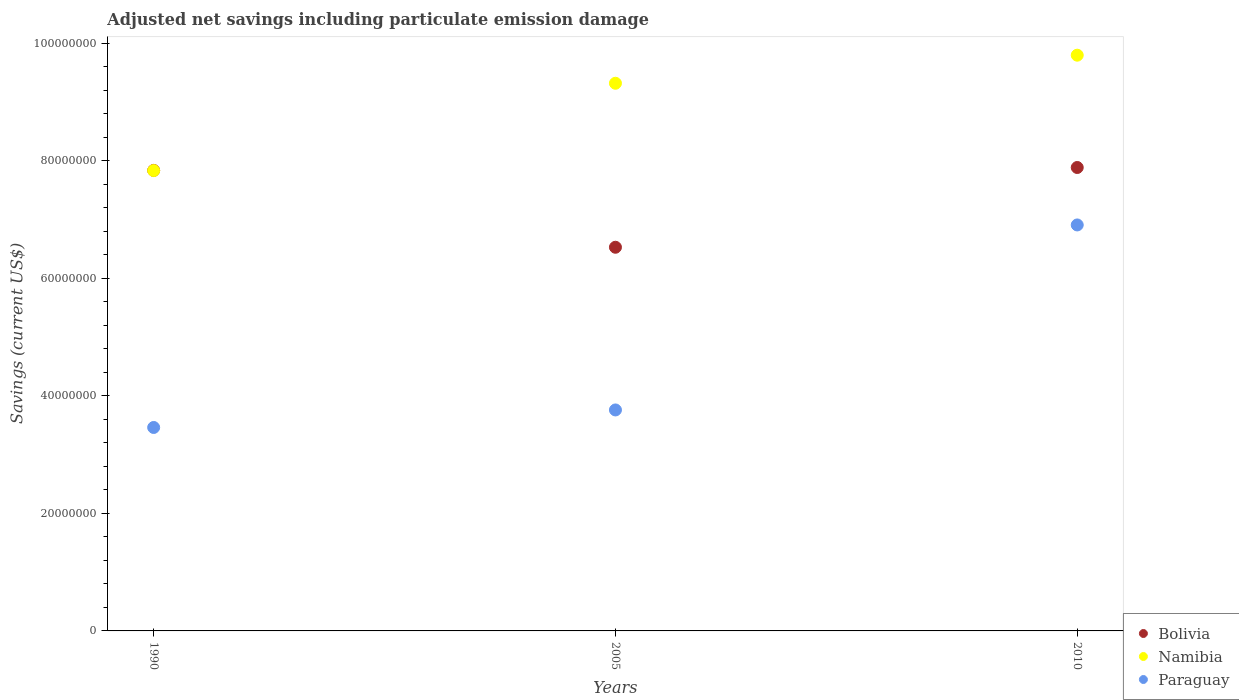How many different coloured dotlines are there?
Keep it short and to the point. 3. What is the net savings in Namibia in 1990?
Your response must be concise. 7.84e+07. Across all years, what is the maximum net savings in Bolivia?
Give a very brief answer. 7.89e+07. Across all years, what is the minimum net savings in Paraguay?
Your answer should be compact. 3.46e+07. In which year was the net savings in Namibia minimum?
Offer a very short reply. 1990. What is the total net savings in Bolivia in the graph?
Provide a succinct answer. 2.23e+08. What is the difference between the net savings in Paraguay in 1990 and that in 2005?
Offer a terse response. -2.98e+06. What is the difference between the net savings in Namibia in 1990 and the net savings in Paraguay in 2005?
Provide a short and direct response. 4.07e+07. What is the average net savings in Paraguay per year?
Provide a short and direct response. 4.71e+07. In the year 2005, what is the difference between the net savings in Paraguay and net savings in Bolivia?
Your answer should be very brief. -2.77e+07. In how many years, is the net savings in Namibia greater than 88000000 US$?
Ensure brevity in your answer.  2. What is the ratio of the net savings in Namibia in 1990 to that in 2010?
Ensure brevity in your answer.  0.8. Is the difference between the net savings in Paraguay in 1990 and 2005 greater than the difference between the net savings in Bolivia in 1990 and 2005?
Give a very brief answer. No. What is the difference between the highest and the second highest net savings in Namibia?
Offer a very short reply. 4.78e+06. What is the difference between the highest and the lowest net savings in Bolivia?
Your response must be concise. 1.36e+07. In how many years, is the net savings in Paraguay greater than the average net savings in Paraguay taken over all years?
Offer a terse response. 1. Does the net savings in Paraguay monotonically increase over the years?
Give a very brief answer. Yes. Is the net savings in Paraguay strictly greater than the net savings in Bolivia over the years?
Ensure brevity in your answer.  No. What is the difference between two consecutive major ticks on the Y-axis?
Offer a very short reply. 2.00e+07. Are the values on the major ticks of Y-axis written in scientific E-notation?
Give a very brief answer. No. Does the graph contain any zero values?
Keep it short and to the point. No. Does the graph contain grids?
Offer a very short reply. No. Where does the legend appear in the graph?
Provide a succinct answer. Bottom right. How are the legend labels stacked?
Offer a terse response. Vertical. What is the title of the graph?
Your answer should be compact. Adjusted net savings including particulate emission damage. What is the label or title of the X-axis?
Provide a short and direct response. Years. What is the label or title of the Y-axis?
Offer a terse response. Savings (current US$). What is the Savings (current US$) in Bolivia in 1990?
Offer a very short reply. 7.84e+07. What is the Savings (current US$) of Namibia in 1990?
Your answer should be compact. 7.84e+07. What is the Savings (current US$) in Paraguay in 1990?
Offer a terse response. 3.46e+07. What is the Savings (current US$) in Bolivia in 2005?
Offer a terse response. 6.53e+07. What is the Savings (current US$) in Namibia in 2005?
Give a very brief answer. 9.32e+07. What is the Savings (current US$) of Paraguay in 2005?
Offer a terse response. 3.76e+07. What is the Savings (current US$) in Bolivia in 2010?
Make the answer very short. 7.89e+07. What is the Savings (current US$) in Namibia in 2010?
Provide a succinct answer. 9.80e+07. What is the Savings (current US$) of Paraguay in 2010?
Provide a short and direct response. 6.91e+07. Across all years, what is the maximum Savings (current US$) in Bolivia?
Your answer should be compact. 7.89e+07. Across all years, what is the maximum Savings (current US$) of Namibia?
Make the answer very short. 9.80e+07. Across all years, what is the maximum Savings (current US$) of Paraguay?
Offer a terse response. 6.91e+07. Across all years, what is the minimum Savings (current US$) of Bolivia?
Make the answer very short. 6.53e+07. Across all years, what is the minimum Savings (current US$) in Namibia?
Provide a short and direct response. 7.84e+07. Across all years, what is the minimum Savings (current US$) of Paraguay?
Your answer should be very brief. 3.46e+07. What is the total Savings (current US$) of Bolivia in the graph?
Your answer should be very brief. 2.23e+08. What is the total Savings (current US$) in Namibia in the graph?
Offer a terse response. 2.70e+08. What is the total Savings (current US$) of Paraguay in the graph?
Keep it short and to the point. 1.41e+08. What is the difference between the Savings (current US$) in Bolivia in 1990 and that in 2005?
Make the answer very short. 1.31e+07. What is the difference between the Savings (current US$) of Namibia in 1990 and that in 2005?
Provide a short and direct response. -1.49e+07. What is the difference between the Savings (current US$) of Paraguay in 1990 and that in 2005?
Offer a terse response. -2.98e+06. What is the difference between the Savings (current US$) in Bolivia in 1990 and that in 2010?
Make the answer very short. -4.93e+05. What is the difference between the Savings (current US$) of Namibia in 1990 and that in 2010?
Your answer should be compact. -1.96e+07. What is the difference between the Savings (current US$) of Paraguay in 1990 and that in 2010?
Your response must be concise. -3.45e+07. What is the difference between the Savings (current US$) in Bolivia in 2005 and that in 2010?
Offer a very short reply. -1.36e+07. What is the difference between the Savings (current US$) in Namibia in 2005 and that in 2010?
Your response must be concise. -4.78e+06. What is the difference between the Savings (current US$) in Paraguay in 2005 and that in 2010?
Give a very brief answer. -3.15e+07. What is the difference between the Savings (current US$) in Bolivia in 1990 and the Savings (current US$) in Namibia in 2005?
Keep it short and to the point. -1.48e+07. What is the difference between the Savings (current US$) in Bolivia in 1990 and the Savings (current US$) in Paraguay in 2005?
Provide a short and direct response. 4.08e+07. What is the difference between the Savings (current US$) in Namibia in 1990 and the Savings (current US$) in Paraguay in 2005?
Give a very brief answer. 4.07e+07. What is the difference between the Savings (current US$) of Bolivia in 1990 and the Savings (current US$) of Namibia in 2010?
Offer a terse response. -1.96e+07. What is the difference between the Savings (current US$) of Bolivia in 1990 and the Savings (current US$) of Paraguay in 2010?
Offer a very short reply. 9.29e+06. What is the difference between the Savings (current US$) of Namibia in 1990 and the Savings (current US$) of Paraguay in 2010?
Make the answer very short. 9.25e+06. What is the difference between the Savings (current US$) in Bolivia in 2005 and the Savings (current US$) in Namibia in 2010?
Offer a very short reply. -3.27e+07. What is the difference between the Savings (current US$) in Bolivia in 2005 and the Savings (current US$) in Paraguay in 2010?
Your response must be concise. -3.80e+06. What is the difference between the Savings (current US$) in Namibia in 2005 and the Savings (current US$) in Paraguay in 2010?
Your answer should be very brief. 2.41e+07. What is the average Savings (current US$) in Bolivia per year?
Your answer should be compact. 7.42e+07. What is the average Savings (current US$) in Namibia per year?
Your answer should be compact. 8.99e+07. What is the average Savings (current US$) in Paraguay per year?
Keep it short and to the point. 4.71e+07. In the year 1990, what is the difference between the Savings (current US$) in Bolivia and Savings (current US$) in Namibia?
Give a very brief answer. 3.24e+04. In the year 1990, what is the difference between the Savings (current US$) in Bolivia and Savings (current US$) in Paraguay?
Keep it short and to the point. 4.38e+07. In the year 1990, what is the difference between the Savings (current US$) in Namibia and Savings (current US$) in Paraguay?
Provide a succinct answer. 4.37e+07. In the year 2005, what is the difference between the Savings (current US$) in Bolivia and Savings (current US$) in Namibia?
Offer a terse response. -2.79e+07. In the year 2005, what is the difference between the Savings (current US$) of Bolivia and Savings (current US$) of Paraguay?
Keep it short and to the point. 2.77e+07. In the year 2005, what is the difference between the Savings (current US$) of Namibia and Savings (current US$) of Paraguay?
Make the answer very short. 5.56e+07. In the year 2010, what is the difference between the Savings (current US$) in Bolivia and Savings (current US$) in Namibia?
Your answer should be very brief. -1.91e+07. In the year 2010, what is the difference between the Savings (current US$) of Bolivia and Savings (current US$) of Paraguay?
Provide a succinct answer. 9.78e+06. In the year 2010, what is the difference between the Savings (current US$) of Namibia and Savings (current US$) of Paraguay?
Offer a very short reply. 2.89e+07. What is the ratio of the Savings (current US$) of Bolivia in 1990 to that in 2005?
Provide a succinct answer. 1.2. What is the ratio of the Savings (current US$) of Namibia in 1990 to that in 2005?
Ensure brevity in your answer.  0.84. What is the ratio of the Savings (current US$) of Paraguay in 1990 to that in 2005?
Make the answer very short. 0.92. What is the ratio of the Savings (current US$) of Namibia in 1990 to that in 2010?
Provide a succinct answer. 0.8. What is the ratio of the Savings (current US$) in Paraguay in 1990 to that in 2010?
Provide a short and direct response. 0.5. What is the ratio of the Savings (current US$) in Bolivia in 2005 to that in 2010?
Offer a very short reply. 0.83. What is the ratio of the Savings (current US$) in Namibia in 2005 to that in 2010?
Your answer should be compact. 0.95. What is the ratio of the Savings (current US$) in Paraguay in 2005 to that in 2010?
Ensure brevity in your answer.  0.54. What is the difference between the highest and the second highest Savings (current US$) of Bolivia?
Give a very brief answer. 4.93e+05. What is the difference between the highest and the second highest Savings (current US$) of Namibia?
Your response must be concise. 4.78e+06. What is the difference between the highest and the second highest Savings (current US$) in Paraguay?
Offer a terse response. 3.15e+07. What is the difference between the highest and the lowest Savings (current US$) of Bolivia?
Offer a very short reply. 1.36e+07. What is the difference between the highest and the lowest Savings (current US$) of Namibia?
Provide a short and direct response. 1.96e+07. What is the difference between the highest and the lowest Savings (current US$) of Paraguay?
Give a very brief answer. 3.45e+07. 